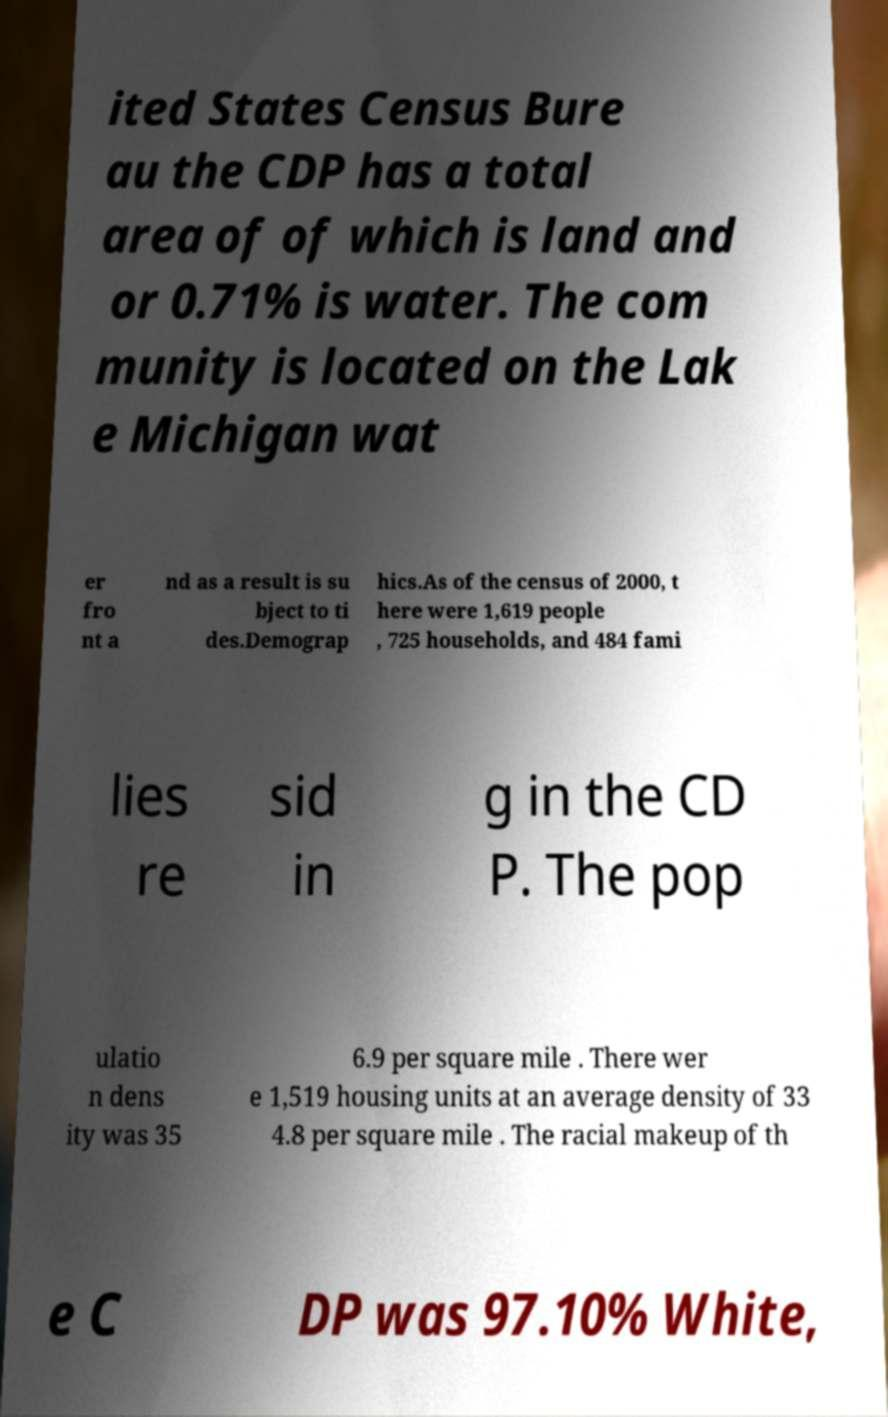What messages or text are displayed in this image? I need them in a readable, typed format. ited States Census Bure au the CDP has a total area of of which is land and or 0.71% is water. The com munity is located on the Lak e Michigan wat er fro nt a nd as a result is su bject to ti des.Demograp hics.As of the census of 2000, t here were 1,619 people , 725 households, and 484 fami lies re sid in g in the CD P. The pop ulatio n dens ity was 35 6.9 per square mile . There wer e 1,519 housing units at an average density of 33 4.8 per square mile . The racial makeup of th e C DP was 97.10% White, 